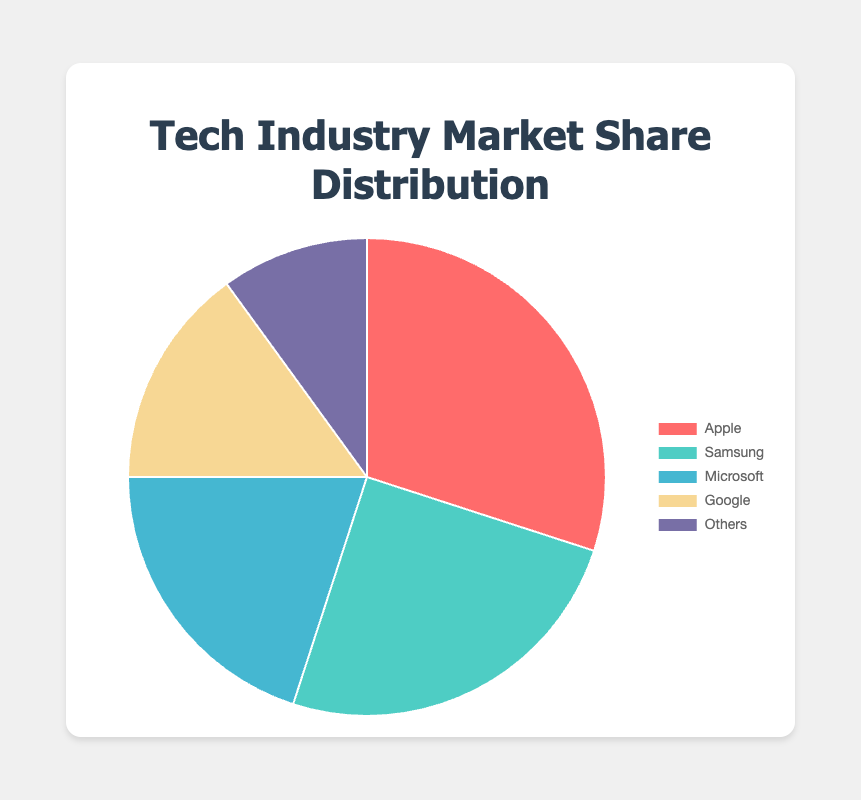Which company has the highest market share? The pie chart shows that the largest slice represents Apple with a market share of 30%.
Answer: Apple What is the combined market share of Samsung and Microsoft? Samsung has a 25% market share, and Microsoft has 20%. Adding these together gives 25% + 20% = 45%.
Answer: 45% Which company's market share is 5% less than the market share of Apple? Apple's market share is 30%. Subtracting 5% from this gives 30% - 5% = 25%. Samsung has a 25% market share.
Answer: Samsung Is the market share of Google equal to the combined market share of "Others" and Microsoft? Google's market share is 15%. The combined market share of "Others" (10%) and Microsoft (20%) is 10% + 20% = 30%, which is not equal to 15%.
Answer: No What is the total market share of Google, Microsoft, and "Others"? Google's market share is 15%, Microsoft's is 20%, and "Others" is 10%. Adding these together: 15% + 20% + 10% = 45%.
Answer: 45% Which segment in the pie chart is represented by the color red? The color red is used to represent Apple, which has a 30% market share as indicated in the pie chart legend.
Answer: Apple How much smaller is Google's market share compared to Apple's? Apple's market share is 30%, and Google's is 15%. The difference is 30% - 15% = 15%.
Answer: 15% What fraction of the total market share is captured by the top two companies? The top two companies by market share are Apple (30%) and Samsung (25%). Together, they capture 30% + 25% = 55% of the total market.
Answer: 55% What is the average market share of all five segments? The market shares are 30%, 25%, 20%, 15%, and 10%. Adding these together gives 100%. Dividing by the number of segments (5) gives 100% / 5 = 20% as the average market share.
Answer: 20% Which two companies together capture a market share equal to Microsoft's? Microsoft's market share is 20%. The combined market share of Google (15%) and "Others" (10%) is 15% + 10% = 25%, which is not equal to 20%. Samsung (25%) alone exceeds 20%. No two companies' shares exactly total 20%, but those closest are Google and "Others" together slightly surpassing it.
Answer: No exact match 